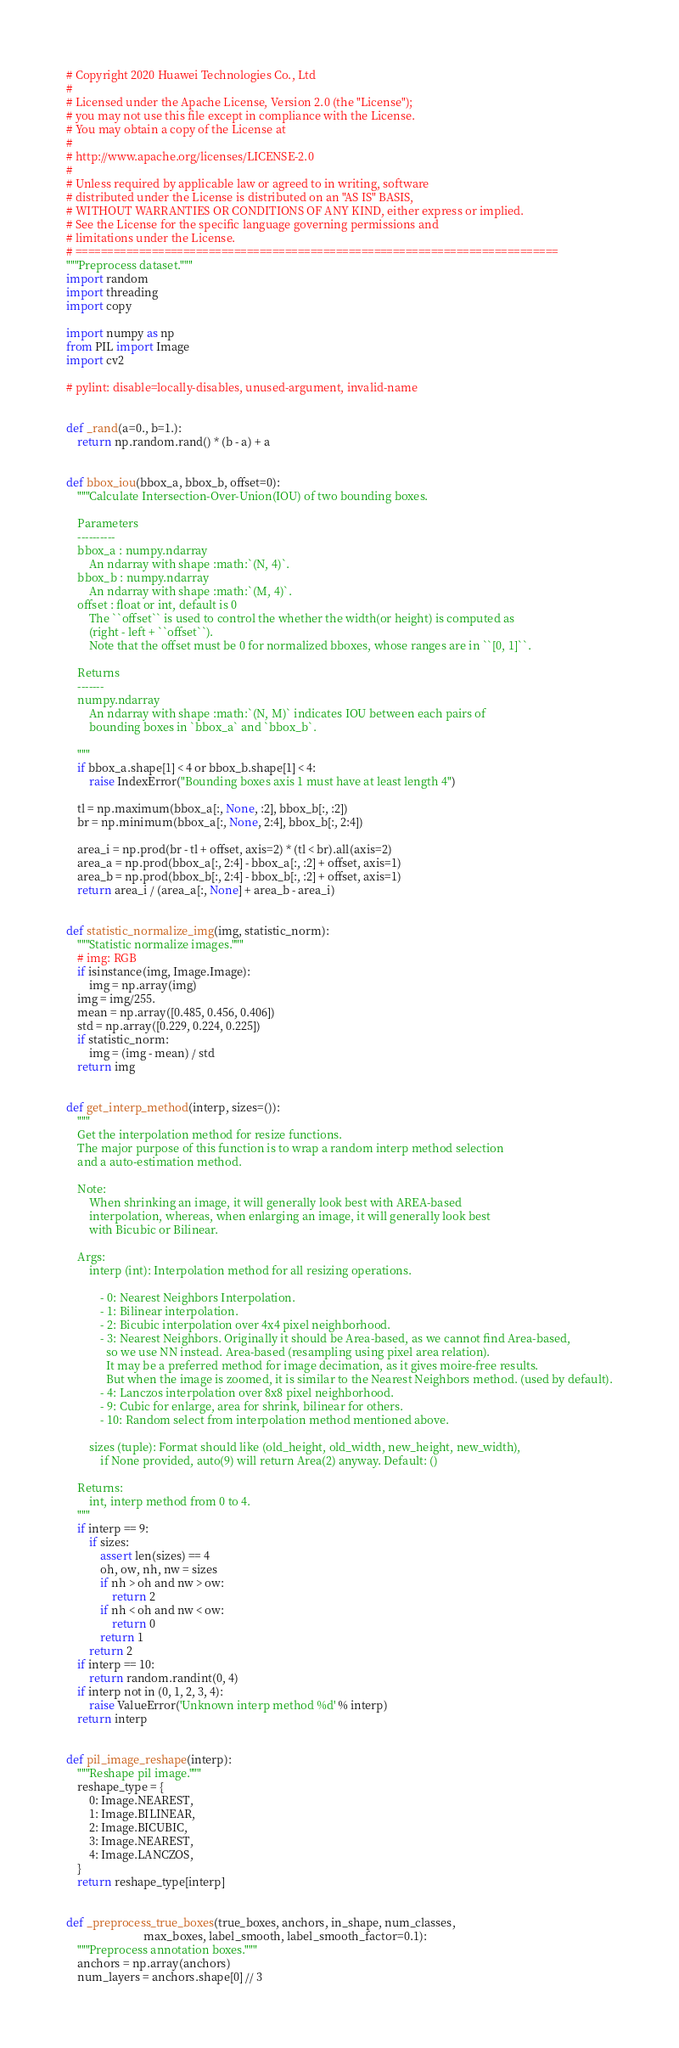<code> <loc_0><loc_0><loc_500><loc_500><_Python_># Copyright 2020 Huawei Technologies Co., Ltd
#
# Licensed under the Apache License, Version 2.0 (the "License");
# you may not use this file except in compliance with the License.
# You may obtain a copy of the License at
#
# http://www.apache.org/licenses/LICENSE-2.0
#
# Unless required by applicable law or agreed to in writing, software
# distributed under the License is distributed on an "AS IS" BASIS,
# WITHOUT WARRANTIES OR CONDITIONS OF ANY KIND, either express or implied.
# See the License for the specific language governing permissions and
# limitations under the License.
# ============================================================================
"""Preprocess dataset."""
import random
import threading
import copy

import numpy as np
from PIL import Image
import cv2

# pylint: disable=locally-disables, unused-argument, invalid-name


def _rand(a=0., b=1.):
    return np.random.rand() * (b - a) + a


def bbox_iou(bbox_a, bbox_b, offset=0):
    """Calculate Intersection-Over-Union(IOU) of two bounding boxes.

    Parameters
    ----------
    bbox_a : numpy.ndarray
        An ndarray with shape :math:`(N, 4)`.
    bbox_b : numpy.ndarray
        An ndarray with shape :math:`(M, 4)`.
    offset : float or int, default is 0
        The ``offset`` is used to control the whether the width(or height) is computed as
        (right - left + ``offset``).
        Note that the offset must be 0 for normalized bboxes, whose ranges are in ``[0, 1]``.

    Returns
    -------
    numpy.ndarray
        An ndarray with shape :math:`(N, M)` indicates IOU between each pairs of
        bounding boxes in `bbox_a` and `bbox_b`.

    """
    if bbox_a.shape[1] < 4 or bbox_b.shape[1] < 4:
        raise IndexError("Bounding boxes axis 1 must have at least length 4")

    tl = np.maximum(bbox_a[:, None, :2], bbox_b[:, :2])
    br = np.minimum(bbox_a[:, None, 2:4], bbox_b[:, 2:4])

    area_i = np.prod(br - tl + offset, axis=2) * (tl < br).all(axis=2)
    area_a = np.prod(bbox_a[:, 2:4] - bbox_a[:, :2] + offset, axis=1)
    area_b = np.prod(bbox_b[:, 2:4] - bbox_b[:, :2] + offset, axis=1)
    return area_i / (area_a[:, None] + area_b - area_i)


def statistic_normalize_img(img, statistic_norm):
    """Statistic normalize images."""
    # img: RGB
    if isinstance(img, Image.Image):
        img = np.array(img)
    img = img/255.
    mean = np.array([0.485, 0.456, 0.406])
    std = np.array([0.229, 0.224, 0.225])
    if statistic_norm:
        img = (img - mean) / std
    return img


def get_interp_method(interp, sizes=()):
    """
    Get the interpolation method for resize functions.
    The major purpose of this function is to wrap a random interp method selection
    and a auto-estimation method.

    Note:
        When shrinking an image, it will generally look best with AREA-based
        interpolation, whereas, when enlarging an image, it will generally look best
        with Bicubic or Bilinear.

    Args:
        interp (int): Interpolation method for all resizing operations.

            - 0: Nearest Neighbors Interpolation.
            - 1: Bilinear interpolation.
            - 2: Bicubic interpolation over 4x4 pixel neighborhood.
            - 3: Nearest Neighbors. Originally it should be Area-based, as we cannot find Area-based,
              so we use NN instead. Area-based (resampling using pixel area relation).
              It may be a preferred method for image decimation, as it gives moire-free results.
              But when the image is zoomed, it is similar to the Nearest Neighbors method. (used by default).
            - 4: Lanczos interpolation over 8x8 pixel neighborhood.
            - 9: Cubic for enlarge, area for shrink, bilinear for others.
            - 10: Random select from interpolation method mentioned above.

        sizes (tuple): Format should like (old_height, old_width, new_height, new_width),
            if None provided, auto(9) will return Area(2) anyway. Default: ()

    Returns:
        int, interp method from 0 to 4.
    """
    if interp == 9:
        if sizes:
            assert len(sizes) == 4
            oh, ow, nh, nw = sizes
            if nh > oh and nw > ow:
                return 2
            if nh < oh and nw < ow:
                return 0
            return 1
        return 2
    if interp == 10:
        return random.randint(0, 4)
    if interp not in (0, 1, 2, 3, 4):
        raise ValueError('Unknown interp method %d' % interp)
    return interp


def pil_image_reshape(interp):
    """Reshape pil image."""
    reshape_type = {
        0: Image.NEAREST,
        1: Image.BILINEAR,
        2: Image.BICUBIC,
        3: Image.NEAREST,
        4: Image.LANCZOS,
    }
    return reshape_type[interp]


def _preprocess_true_boxes(true_boxes, anchors, in_shape, num_classes,
                           max_boxes, label_smooth, label_smooth_factor=0.1):
    """Preprocess annotation boxes."""
    anchors = np.array(anchors)
    num_layers = anchors.shape[0] // 3</code> 